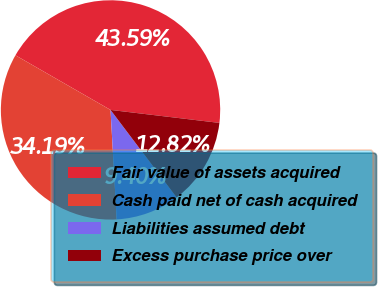<chart> <loc_0><loc_0><loc_500><loc_500><pie_chart><fcel>Fair value of assets acquired<fcel>Cash paid net of cash acquired<fcel>Liabilities assumed debt<fcel>Excess purchase price over<nl><fcel>43.59%<fcel>34.19%<fcel>9.4%<fcel>12.82%<nl></chart> 